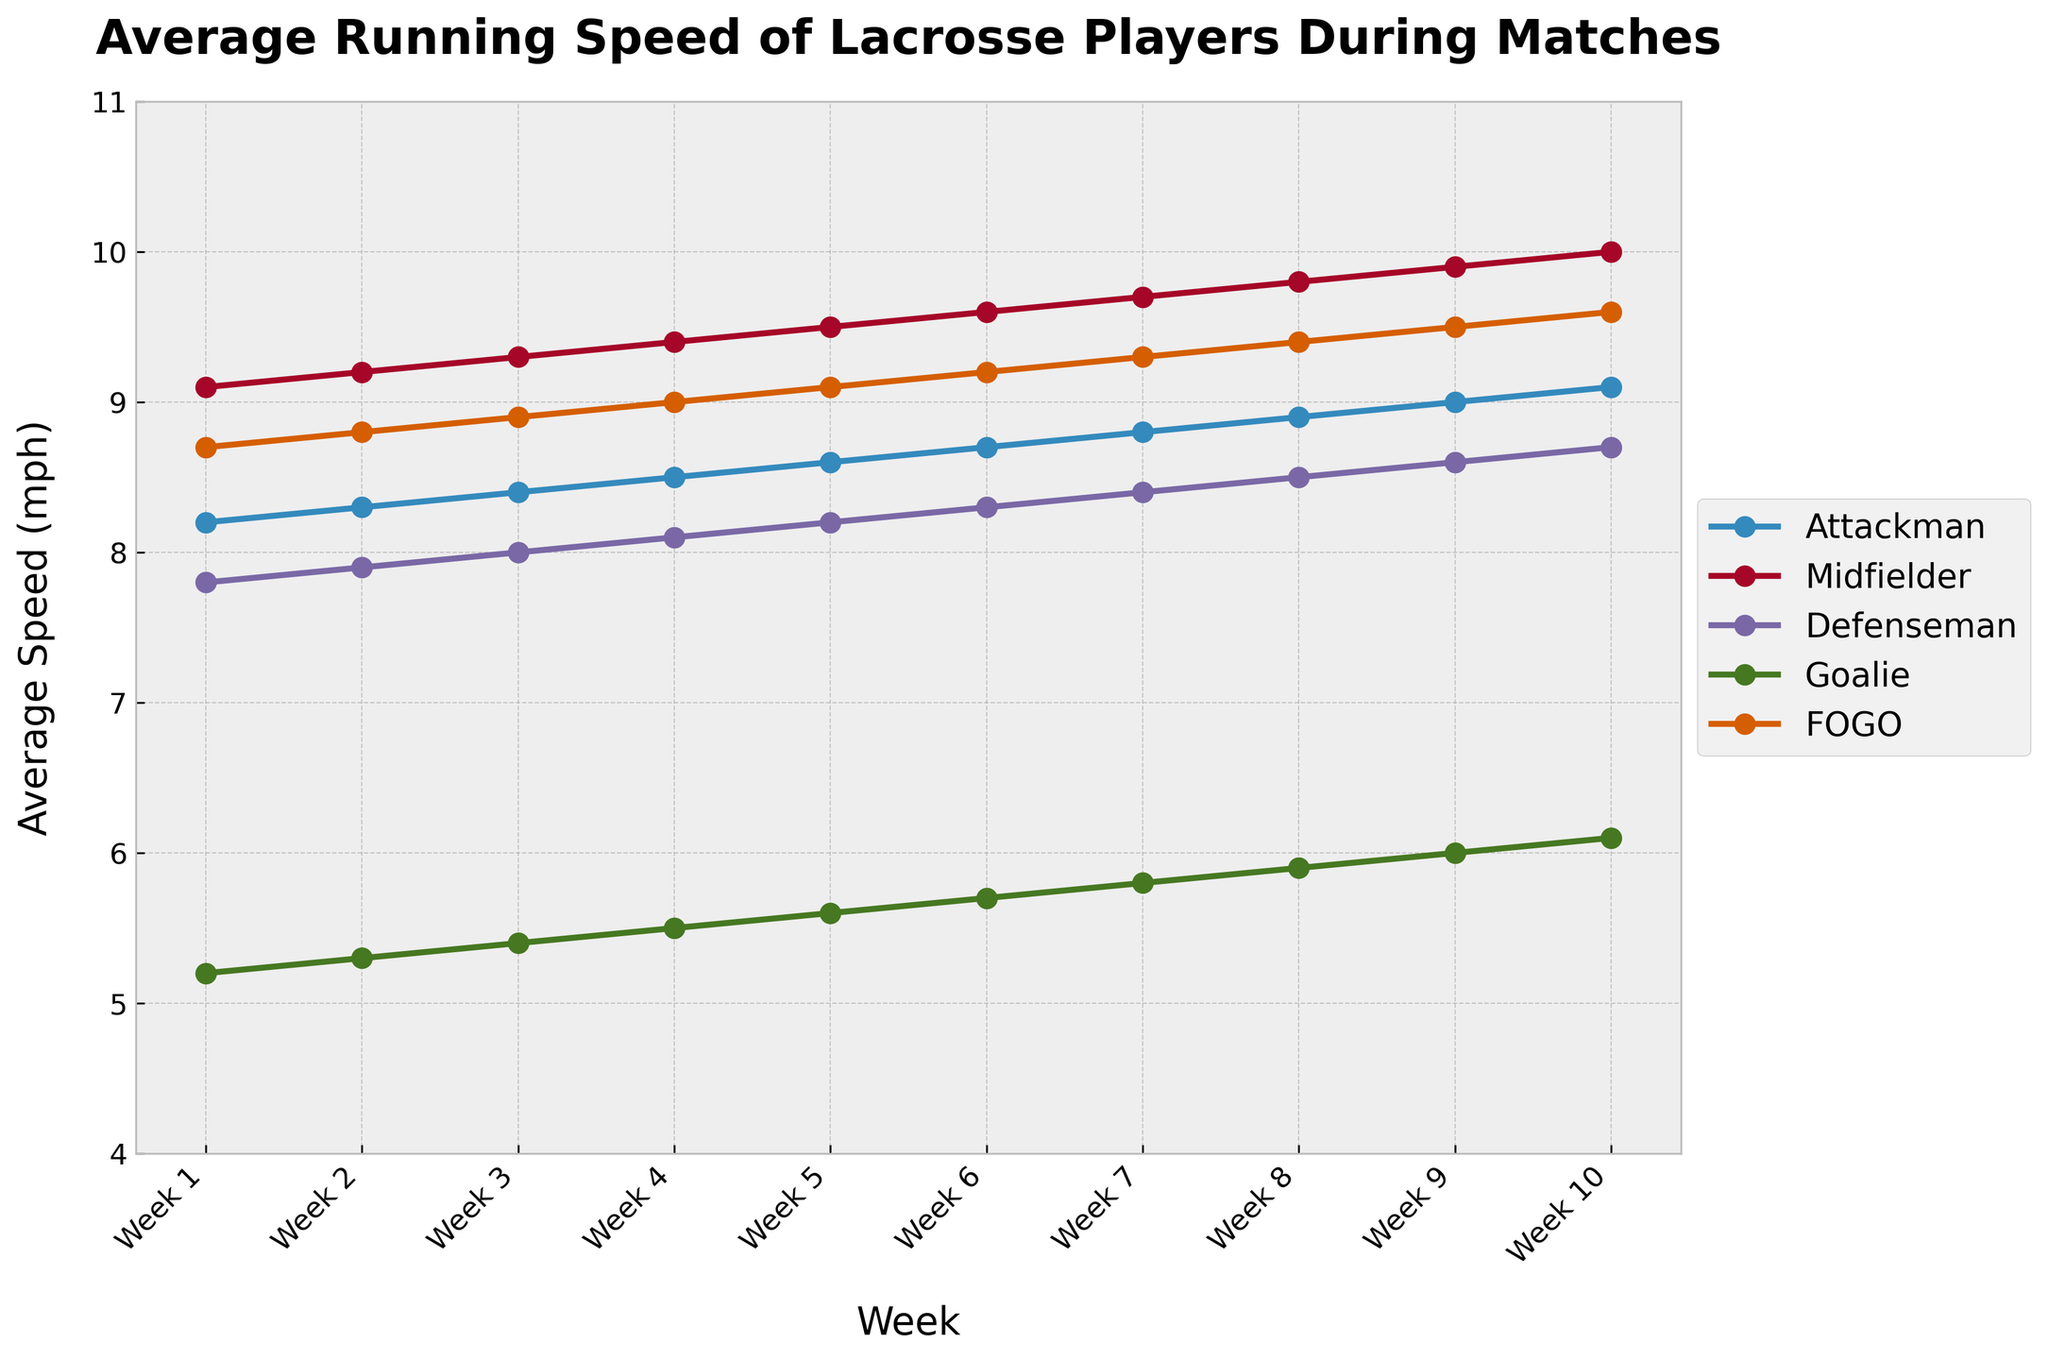What's the average speed of the Attackman over the entire season? To find the average speed of the Attackman over the season, sum up their speeds for each week and then divide by the number of weeks. Specifically, (8.2 + 8.3 + 8.4 + 8.5 + 8.6 + 8.7 + 8.8 + 8.9 + 9.0 + 9.1) / 10 = 86.5 / 10.
Answer: 8.65 How does the speed of the Goalie compare to the speed of an Attackman in Week 5? The speed of the Goalie in Week 5 is 5.6 mph, while the speed of the Attackman in the same week is 8.6 mph. Comparing these values, 5.6 mph (Goalie) < 8.6 mph (Attackman).
Answer: The Goalie is slower Which position shows the highest average speed in Week 10? By comparing the speeds of all positions in Week 10, we see that the Midfielder has the highest speed of 10.0 mph.
Answer: Midfielder What is the overall trend of the Defenseman's speed throughout the season? Observing the graph for the Defenseman's speed, it consistently increases from Week 1 (7.8 mph) to Week 10 (8.7 mph).
Answer: Increasing Calculate the difference between the FOGO’s and Midfielder’s speeds in Week 1 and in Week 10. For Week 1, Midfielder's speed is 9.1 mph and FOGO’s is 8.7 mph, so the difference is 9.1 - 8.7 = 0.4 mph. For Week 10, Midfielder's speed is 10.0 mph, and FOGO’s is 9.6 mph, so the difference is 10.0 - 9.6 = 0.4 mph.
Answer: 0.4 mph for both weeks Does the speed of any position remain constant throughout the season? By examining the lines on the chart, it is evident that all positions show an upward trend in speed, indicating no constant speed throughout the season.
Answer: No Which position has the greatest increase in speed from Week 1 to Week 10? Calculate the increase for each position: 
- Attackman: 9.1 - 8.2 = 0.9 mph
- Midfielder: 10.0 - 9.1 = 0.9 mph
- Defenseman: 8.7 - 7.8 = 0.9 mph
- Goalie: 6.1 - 5.2 = 0.9 mph
- FOGO: 9.6 - 8.7 = 0.9 mph
Since all increases are the same, no single position has the greatest increase.
Answer: All positions have the same increase What is the range of speeds for the Midfielder over the season? The range is calculated by subtracting the lowest speed from the highest speed for the Midfielder:
- Highest speed: 10.0 mph (Week 10)
- Lowest speed: 9.1 mph (Week 1)
Range = 10.0 - 9.1 = 0.9 mph.
Answer: 0.9 mph Which position had the closest average speed to 9 mph? First, find the average speeds over the season for each position:
- Attackman: 8.65 mph
- Midfielder: 9.55 mph
- Defenseman: 8.25 mph
- Goalie: 5.85 mph
- FOGO: 9.15 mph
The FOGO's average speed of 9.15 mph is the closest to 9 mph.
Answer: FOGO 